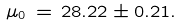Convert formula to latex. <formula><loc_0><loc_0><loc_500><loc_500>\mu _ { 0 } \, = \, 2 8 . 2 2 \pm 0 . 2 1 .</formula> 